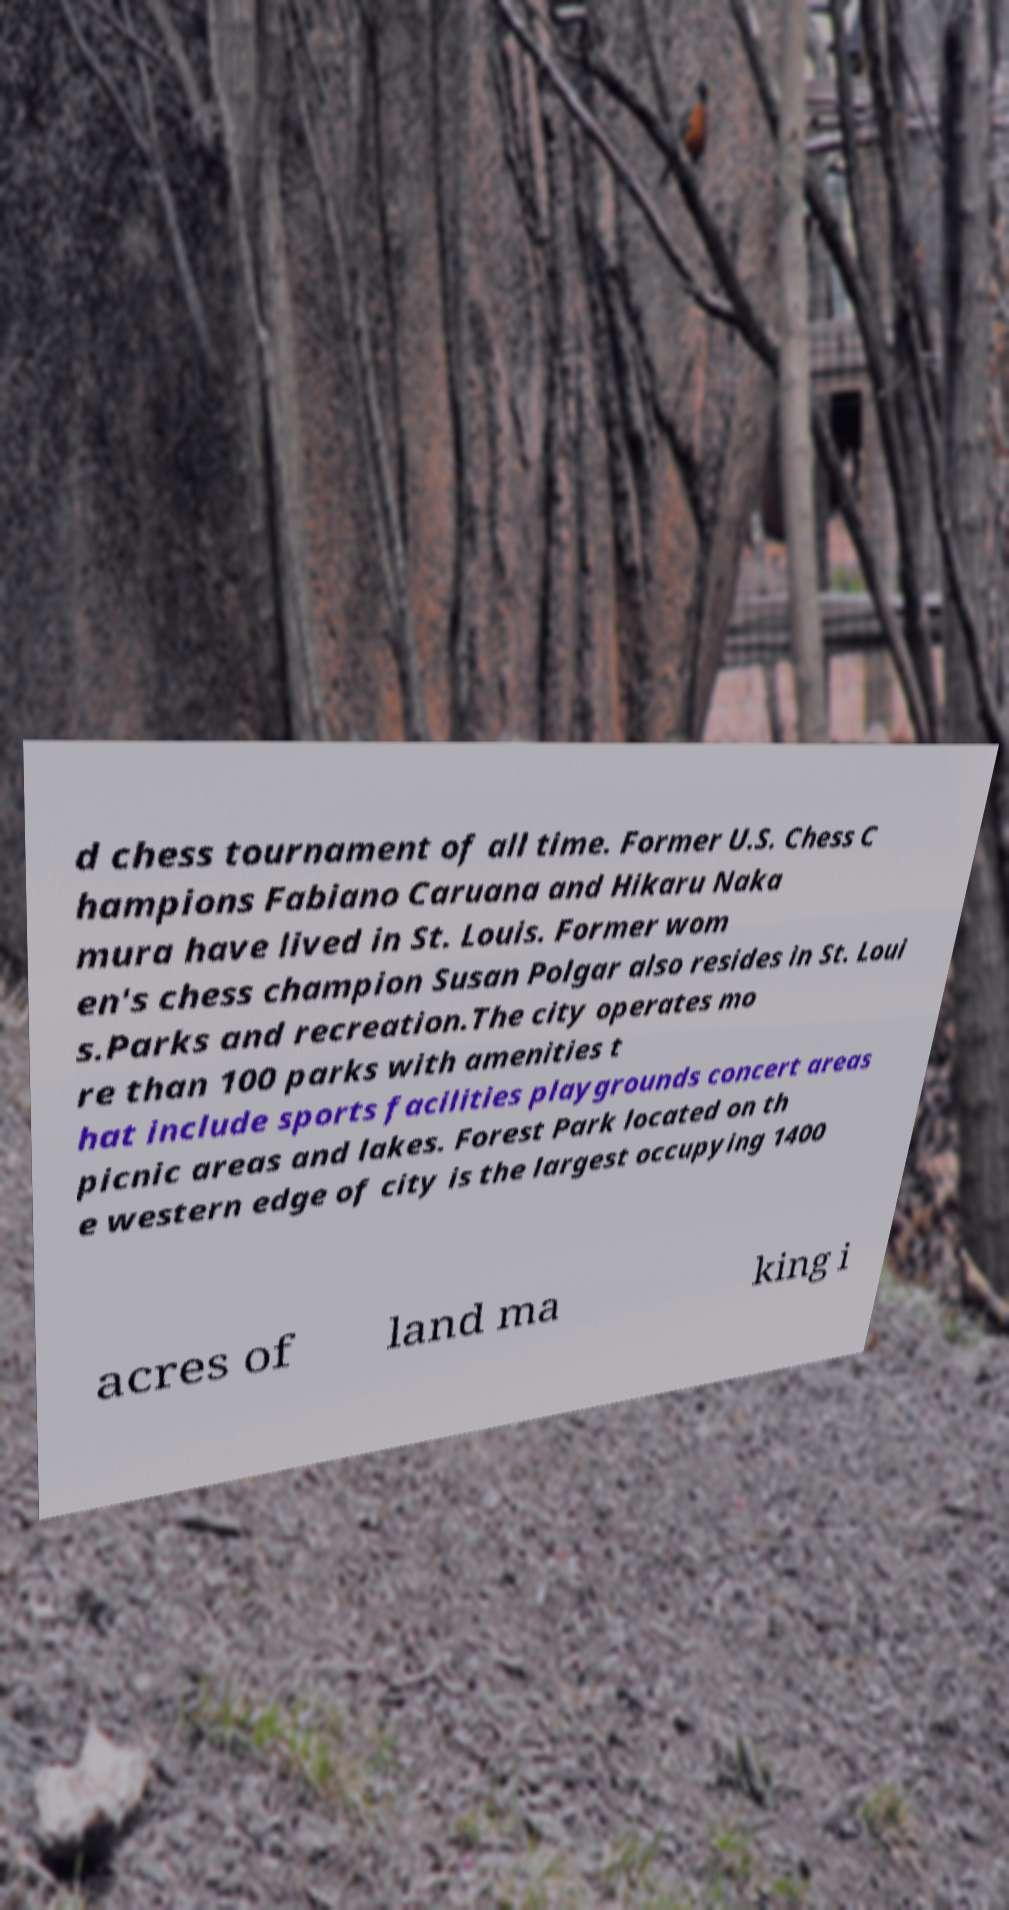Can you accurately transcribe the text from the provided image for me? d chess tournament of all time. Former U.S. Chess C hampions Fabiano Caruana and Hikaru Naka mura have lived in St. Louis. Former wom en's chess champion Susan Polgar also resides in St. Loui s.Parks and recreation.The city operates mo re than 100 parks with amenities t hat include sports facilities playgrounds concert areas picnic areas and lakes. Forest Park located on th e western edge of city is the largest occupying 1400 acres of land ma king i 